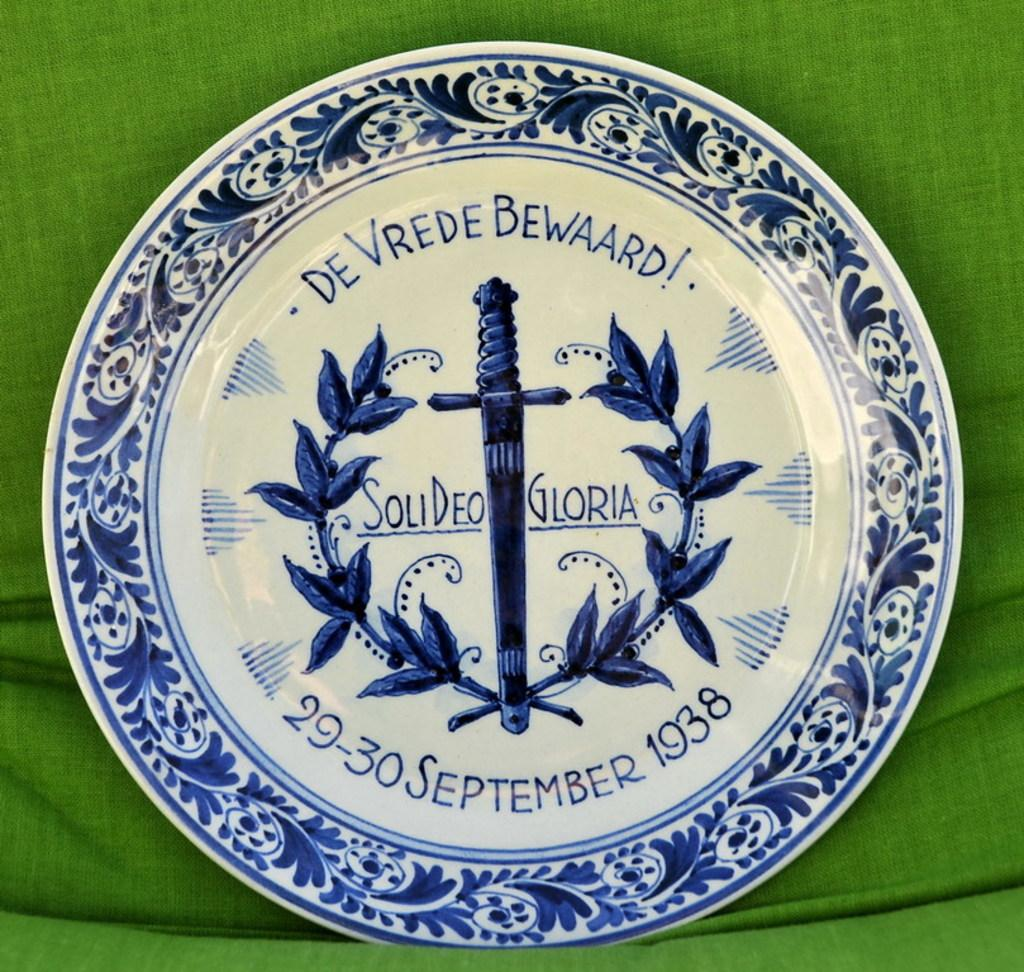What object is present in the image that might be used for serving food? There is a plate in the image that might be used for serving food. Can you describe the appearance of the plate? The plate has a design on it and text. What color or material is the cloth in the background of the image? The cloth in the background of the image is green. What type of representative is depicted on the plate in the image? There is no representative depicted on the plate in the image; it only has a design and text. Can you tell me how much heat the box in the image can withstand? There is no box present in the image, so it is not possible to determine its heat resistance. 